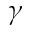Convert formula to latex. <formula><loc_0><loc_0><loc_500><loc_500>\gamma</formula> 